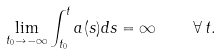<formula> <loc_0><loc_0><loc_500><loc_500>\lim _ { t _ { 0 } \to - \infty } \int _ { t _ { 0 } } ^ { t } a ( s ) d s = \infty \quad \forall \, t .</formula> 